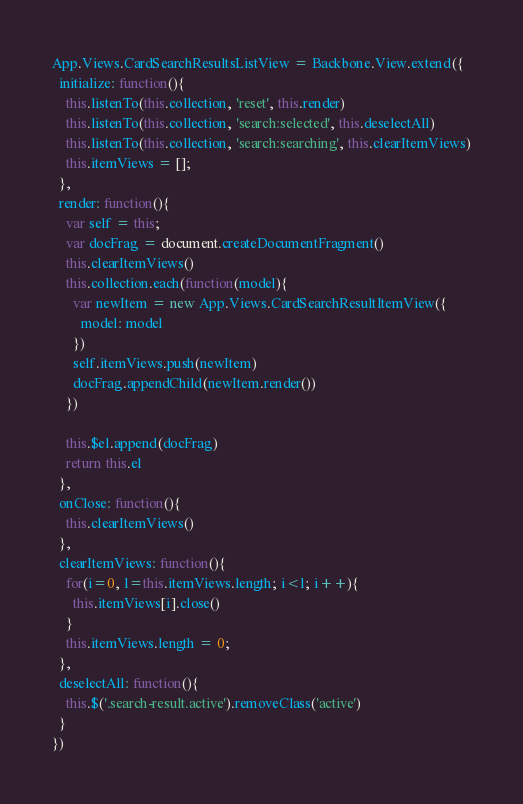Convert code to text. <code><loc_0><loc_0><loc_500><loc_500><_JavaScript_>App.Views.CardSearchResultsListView = Backbone.View.extend({
  initialize: function(){
    this.listenTo(this.collection, 'reset', this.render)
    this.listenTo(this.collection, 'search:selected', this.deselectAll)
    this.listenTo(this.collection, 'search:searching', this.clearItemViews)
    this.itemViews = [];
  },
  render: function(){
    var self = this;
    var docFrag = document.createDocumentFragment()
    this.clearItemViews()
    this.collection.each(function(model){
      var newItem = new App.Views.CardSearchResultItemView({
        model: model
      })
      self.itemViews.push(newItem)
      docFrag.appendChild(newItem.render())
    })

    this.$el.append(docFrag)
    return this.el
  },
  onClose: function(){
    this.clearItemViews()
  },
  clearItemViews: function(){
    for(i=0, l=this.itemViews.length; i<l; i++){
      this.itemViews[i].close()
    }
    this.itemViews.length = 0;
  },
  deselectAll: function(){
    this.$('.search-result.active').removeClass('active')
  }
})</code> 